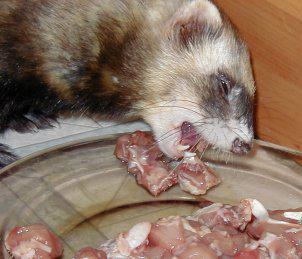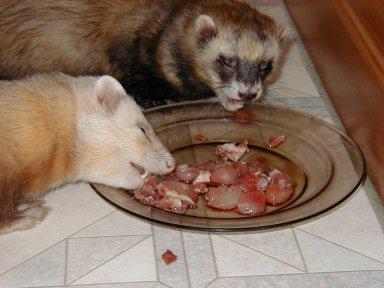The first image is the image on the left, the second image is the image on the right. For the images displayed, is the sentence "At least four ferrets are in the same container in one image." factually correct? Answer yes or no. No. The first image is the image on the left, the second image is the image on the right. Given the left and right images, does the statement "At least one baby ferret is being held by a human hand." hold true? Answer yes or no. No. 